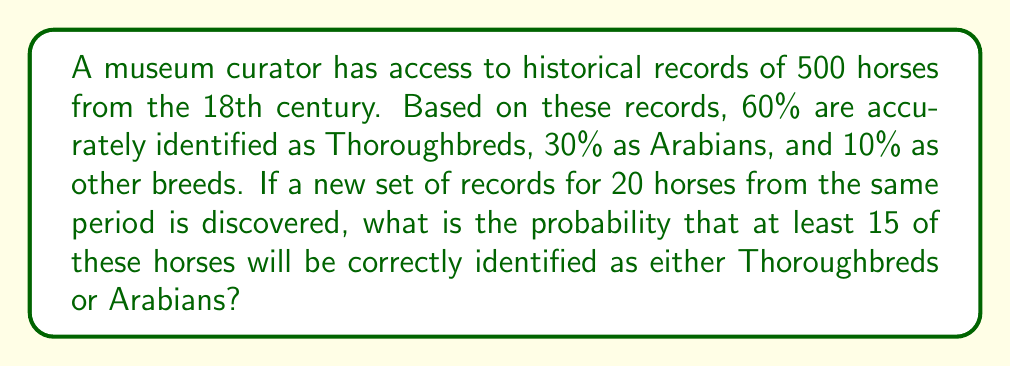Can you solve this math problem? Let's approach this step-by-step:

1) First, we need to calculate the probability of correctly identifying a horse as either a Thoroughbred or Arabian. This is the sum of their individual probabilities:

   $P(\text{Thoroughbred or Arabian}) = 0.60 + 0.30 = 0.90$

2) Now, we can treat this as a binomial probability problem. We want the probability of at least 15 successes out of 20 trials, where each trial has a 0.90 probability of success.

3) We can calculate this by finding the probability of 15, 16, 17, 18, 19, or 20 successes and summing these probabilities.

4) The binomial probability formula is:

   $$P(X=k) = \binom{n}{k} p^k (1-p)^{n-k}$$

   where $n$ is the number of trials, $k$ is the number of successes, $p$ is the probability of success on each trial.

5) Let's calculate for each case:

   For 15 successes: $\binom{20}{15} (0.90)^{15} (0.10)^5 = 0.0374$
   For 16 successes: $\binom{20}{16} (0.90)^{16} (0.10)^4 = 0.1122$
   For 17 successes: $\binom{20}{17} (0.90)^{17} (0.10)^3 = 0.2367$
   For 18 successes: $\binom{20}{18} (0.90)^{18} (0.10)^2 = 0.3389$
   For 19 successes: $\binom{20}{19} (0.90)^{19} (0.10)^1 = 0.2669$
   For 20 successes: $\binom{20}{20} (0.90)^{20} (0.10)^0 = 0.1216$

6) The sum of these probabilities is:

   $0.0374 + 0.1122 + 0.2367 + 0.3389 + 0.2669 + 0.1216 = 0.9137$

Therefore, the probability of correctly identifying at least 15 out of 20 horses as either Thoroughbreds or Arabians is approximately 0.9137 or 91.37%.
Answer: 0.9137 